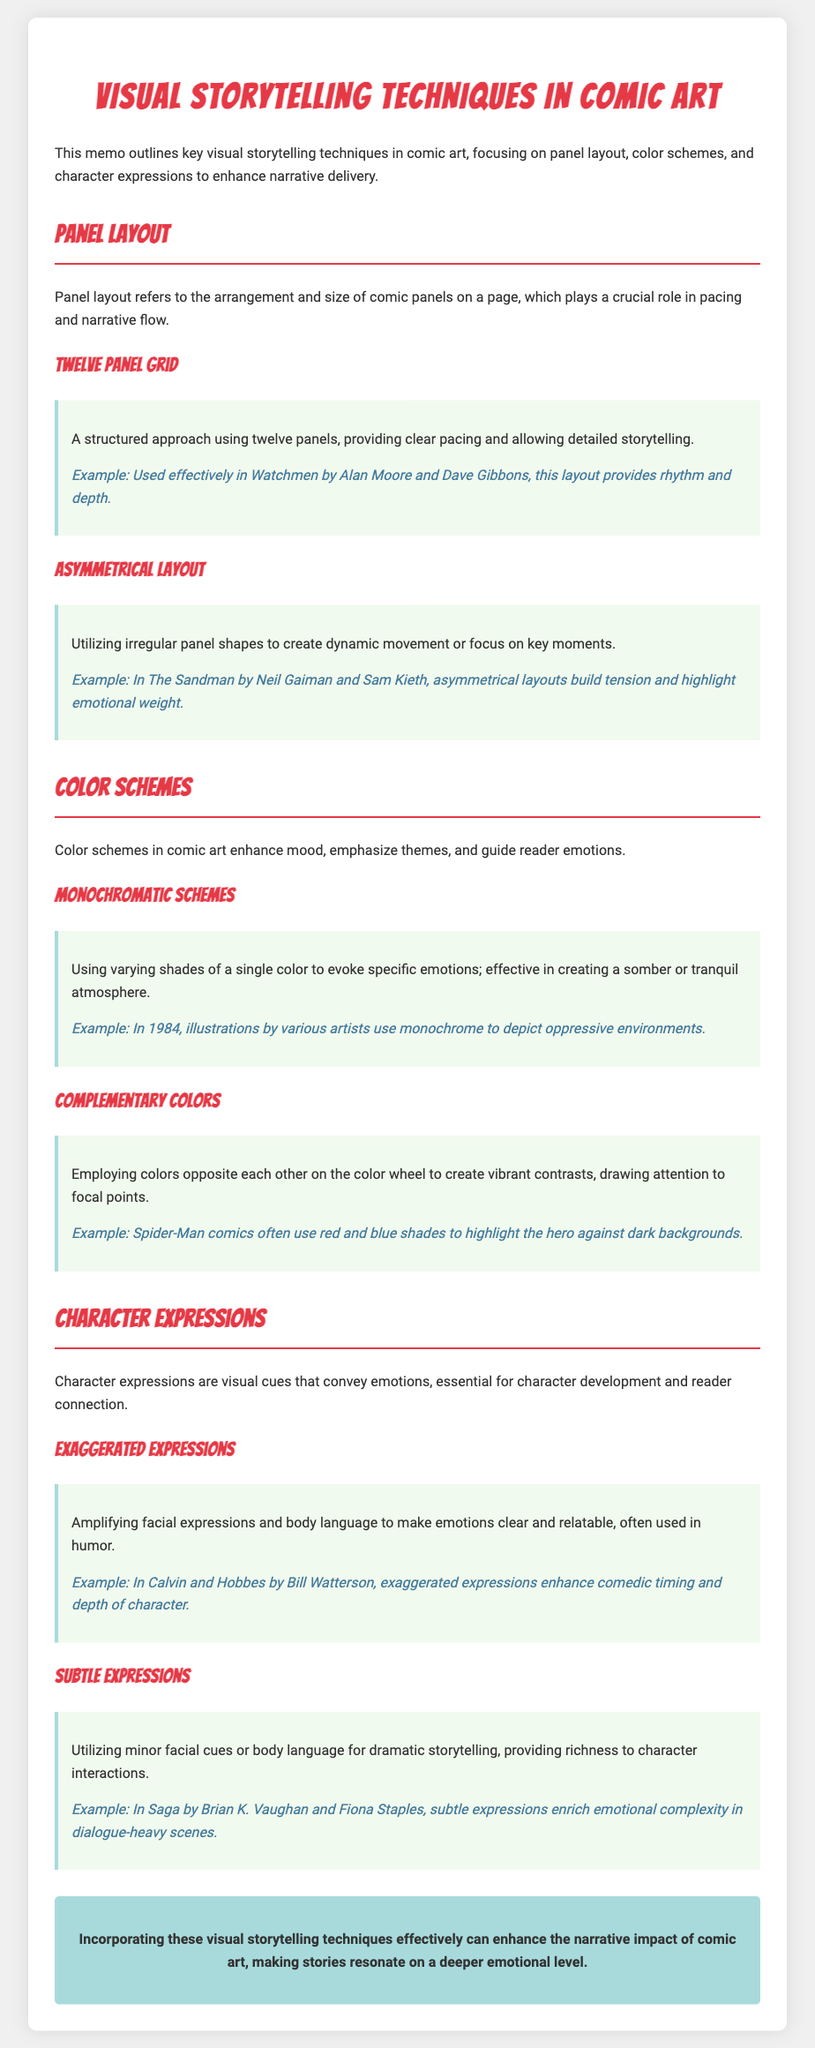What are key visual storytelling techniques in comic art? The document outlines techniques including panel layout, color schemes, and character expressions.
Answer: Panel layout, color schemes, character expressions What is the example comic for the twelve panel grid? The example provided for the twelve panel grid technique is "Watchmen" by Alan Moore and Dave Gibbons.
Answer: Watchmen Which color scheme uses varying shades of a single color? The monochromatic scheme uses varying shades of a single color to evoke specific emotions.
Answer: Monochromatic In which comic is the character's exaggerated expression used effectively in humor? The exaggerated expressions are effectively used in "Calvin and Hobbes" by Bill Watterson.
Answer: Calvin and Hobbes What layout creates dynamic movement or focuses on key moments? The asymmetrical layout utilizes irregular panel shapes to create dynamic movement or focus.
Answer: Asymmetrical layout Which colors are used in Spider-Man comics to create vibrant contrasts? Spider-Man comics often use red and blue shades to highlight the hero against dark backgrounds.
Answer: Red and blue What type of expressions are used to enhance comedic timing? Exaggerated expressions are amplified to enhance comedic timing and depth of character.
Answer: Exaggerated expressions What is the purpose of subtle expressions in comics? Subtle expressions provide richness to character interactions by utilizing minor facial cues.
Answer: Richness to character interactions What technique emphasizes emotional complexity in dialogue-heavy scenes? The technique of using subtle expressions emphasizes emotional complexity in dialogue-heavy scenes.
Answer: Subtle expressions 